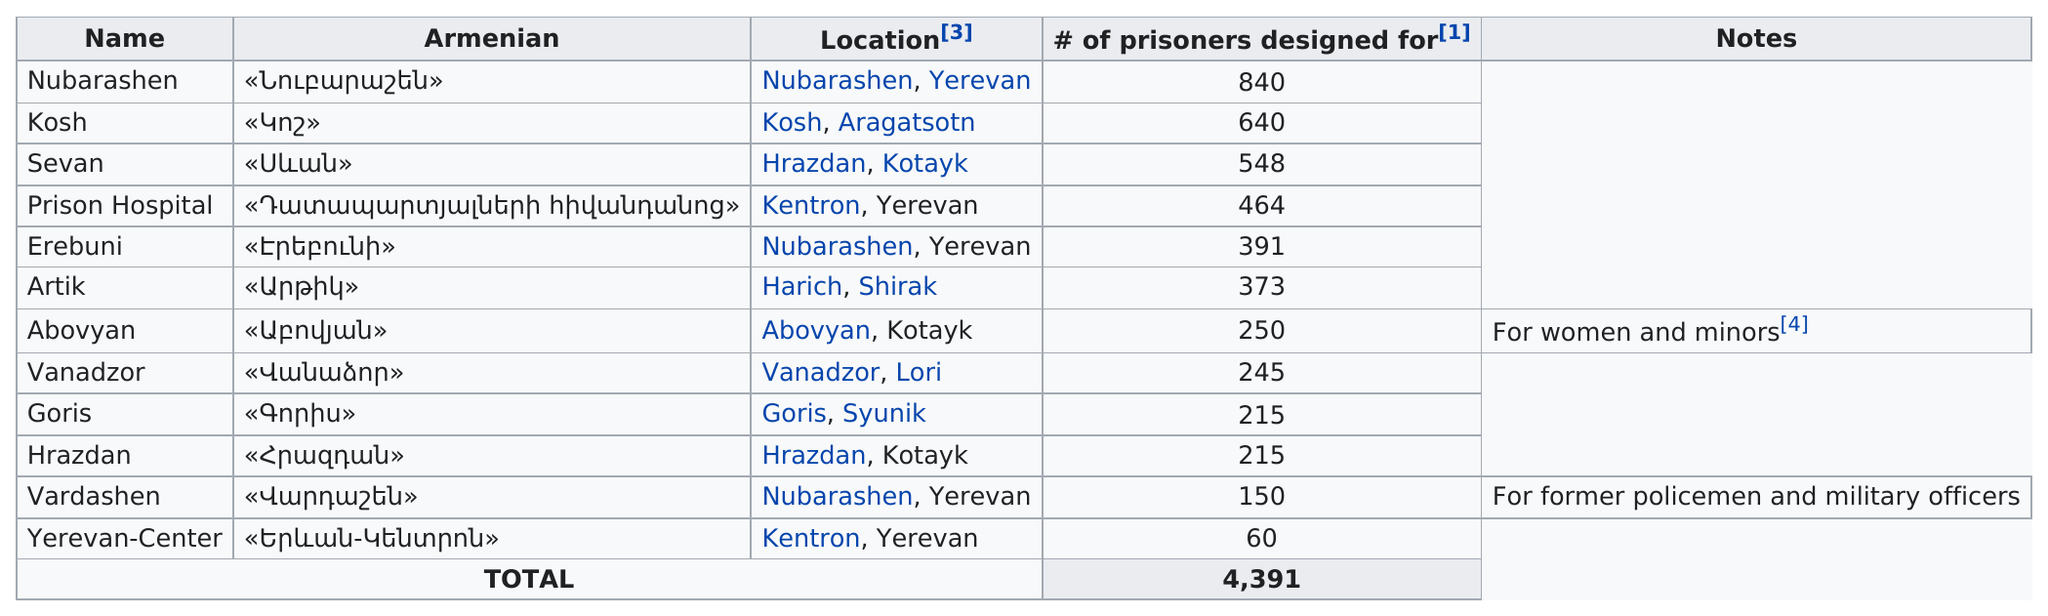Indicate a few pertinent items in this graphic. The total number of prisoners in Goris and Erebuni combined is 606. The design of the Yerevan-Center correctional facility was specifically intended for a maximum capacity of less than 200 prisoners. There were prisons designed to hold at least 200 inmates. There are three prisons in Nubarashen. After the construction of the Mausoleum of Persian Kings, the most well-known was the construction of the Palace of Persepolis, which was designed to hold the largest number of prisoners. 